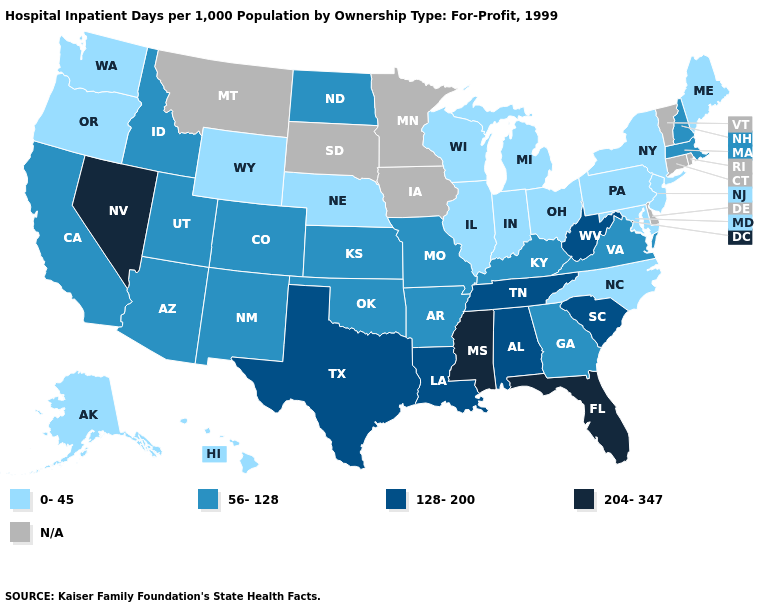Name the states that have a value in the range 204-347?
Short answer required. Florida, Mississippi, Nevada. Does West Virginia have the lowest value in the USA?
Quick response, please. No. Name the states that have a value in the range N/A?
Be succinct. Connecticut, Delaware, Iowa, Minnesota, Montana, Rhode Island, South Dakota, Vermont. What is the highest value in the USA?
Be succinct. 204-347. Among the states that border Kentucky , does West Virginia have the highest value?
Keep it brief. Yes. Which states have the highest value in the USA?
Answer briefly. Florida, Mississippi, Nevada. Name the states that have a value in the range 204-347?
Keep it brief. Florida, Mississippi, Nevada. Name the states that have a value in the range 56-128?
Quick response, please. Arizona, Arkansas, California, Colorado, Georgia, Idaho, Kansas, Kentucky, Massachusetts, Missouri, New Hampshire, New Mexico, North Dakota, Oklahoma, Utah, Virginia. Name the states that have a value in the range 204-347?
Give a very brief answer. Florida, Mississippi, Nevada. What is the value of Colorado?
Concise answer only. 56-128. Name the states that have a value in the range 0-45?
Short answer required. Alaska, Hawaii, Illinois, Indiana, Maine, Maryland, Michigan, Nebraska, New Jersey, New York, North Carolina, Ohio, Oregon, Pennsylvania, Washington, Wisconsin, Wyoming. What is the lowest value in the USA?
Concise answer only. 0-45. Name the states that have a value in the range 0-45?
Concise answer only. Alaska, Hawaii, Illinois, Indiana, Maine, Maryland, Michigan, Nebraska, New Jersey, New York, North Carolina, Ohio, Oregon, Pennsylvania, Washington, Wisconsin, Wyoming. What is the highest value in states that border Colorado?
Quick response, please. 56-128. Does Florida have the highest value in the USA?
Short answer required. Yes. 